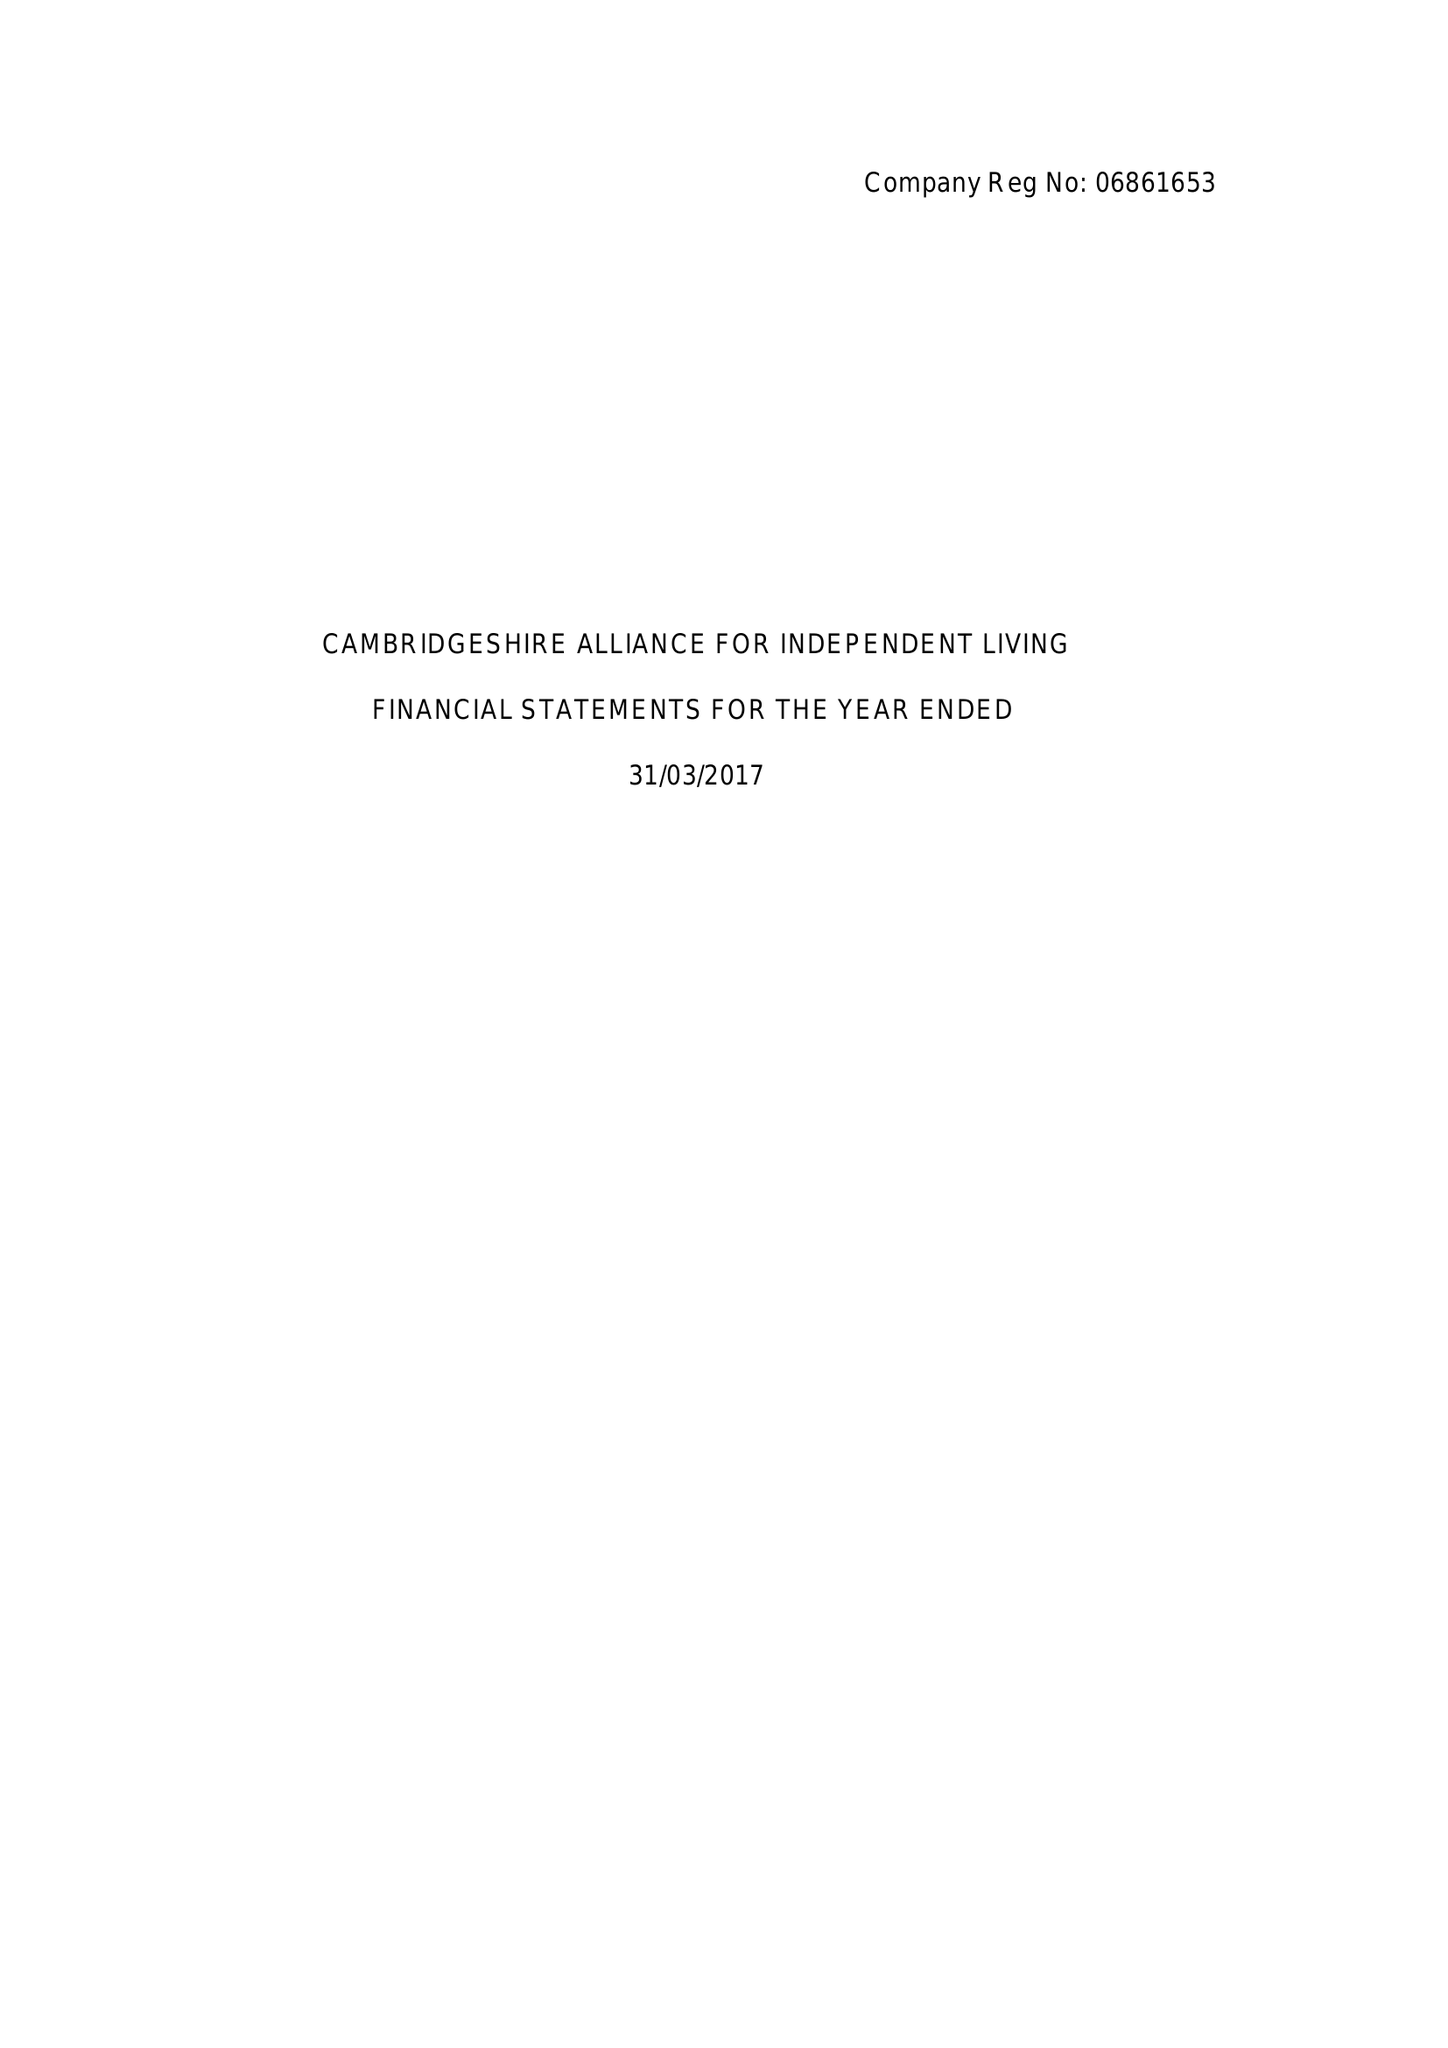What is the value for the income_annually_in_british_pounds?
Answer the question using a single word or phrase. 114646.00 